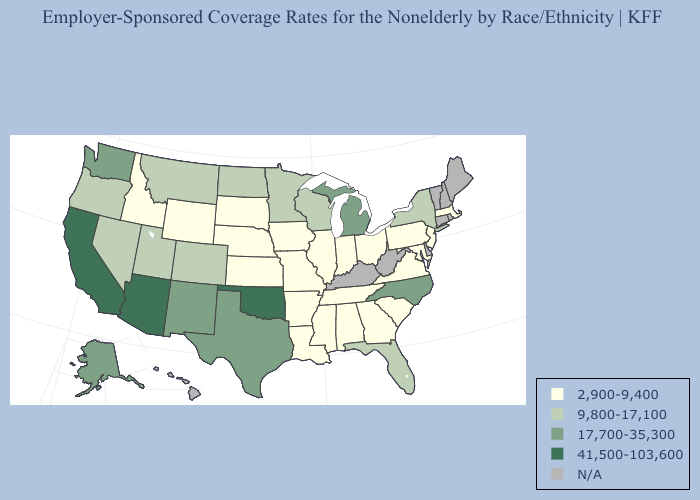What is the lowest value in the USA?
Quick response, please. 2,900-9,400. What is the value of Alaska?
Quick response, please. 17,700-35,300. Among the states that border Missouri , which have the lowest value?
Give a very brief answer. Arkansas, Illinois, Iowa, Kansas, Nebraska, Tennessee. What is the value of North Dakota?
Write a very short answer. 9,800-17,100. What is the lowest value in the South?
Short answer required. 2,900-9,400. Name the states that have a value in the range 17,700-35,300?
Be succinct. Alaska, Michigan, New Mexico, North Carolina, Texas, Washington. Does the map have missing data?
Concise answer only. Yes. What is the value of Iowa?
Concise answer only. 2,900-9,400. What is the highest value in the USA?
Concise answer only. 41,500-103,600. What is the value of Utah?
Quick response, please. 9,800-17,100. Name the states that have a value in the range 2,900-9,400?
Give a very brief answer. Alabama, Arkansas, Georgia, Idaho, Illinois, Indiana, Iowa, Kansas, Louisiana, Maryland, Massachusetts, Mississippi, Missouri, Nebraska, New Jersey, Ohio, Pennsylvania, South Carolina, South Dakota, Tennessee, Virginia, Wyoming. Among the states that border Arkansas , which have the highest value?
Answer briefly. Oklahoma. What is the highest value in states that border Utah?
Short answer required. 41,500-103,600. What is the value of Minnesota?
Be succinct. 9,800-17,100. 